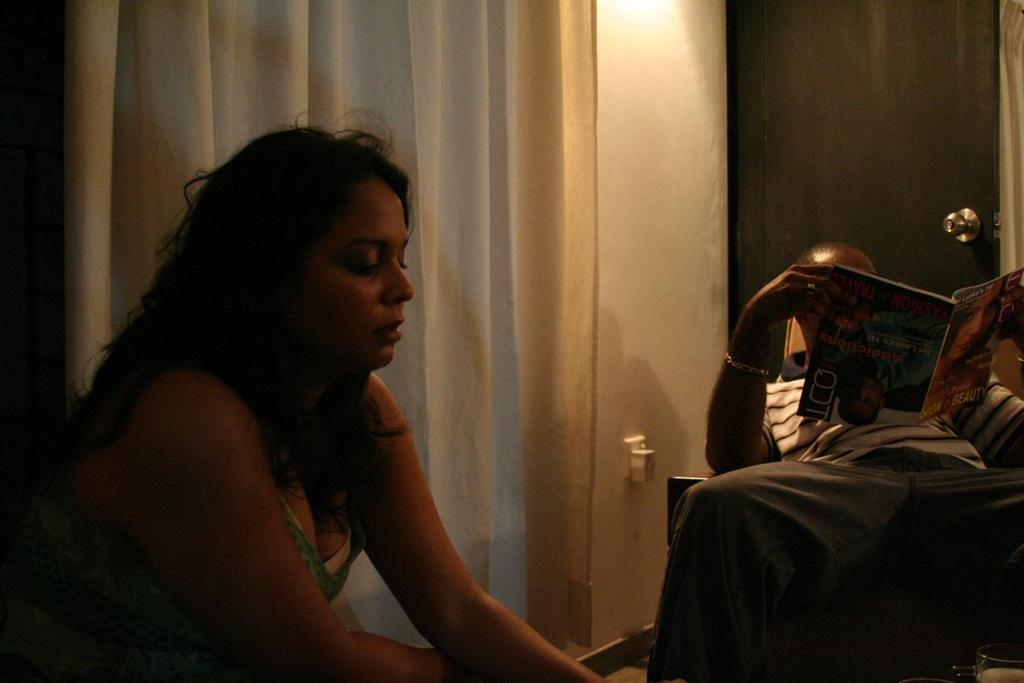What is the man in the image holding? The man is holding a book. Who is in front of the man in the image? There is a woman in front of the man. What can be seen in the background of the image? There is a door, a curtain, a wall, and some objects in the background of the image. What type of rhythm does the plastic scale have in the image? There is no rhythm, plastic, or scale present in the image. 